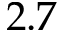Convert formula to latex. <formula><loc_0><loc_0><loc_500><loc_500>2 . 7</formula> 